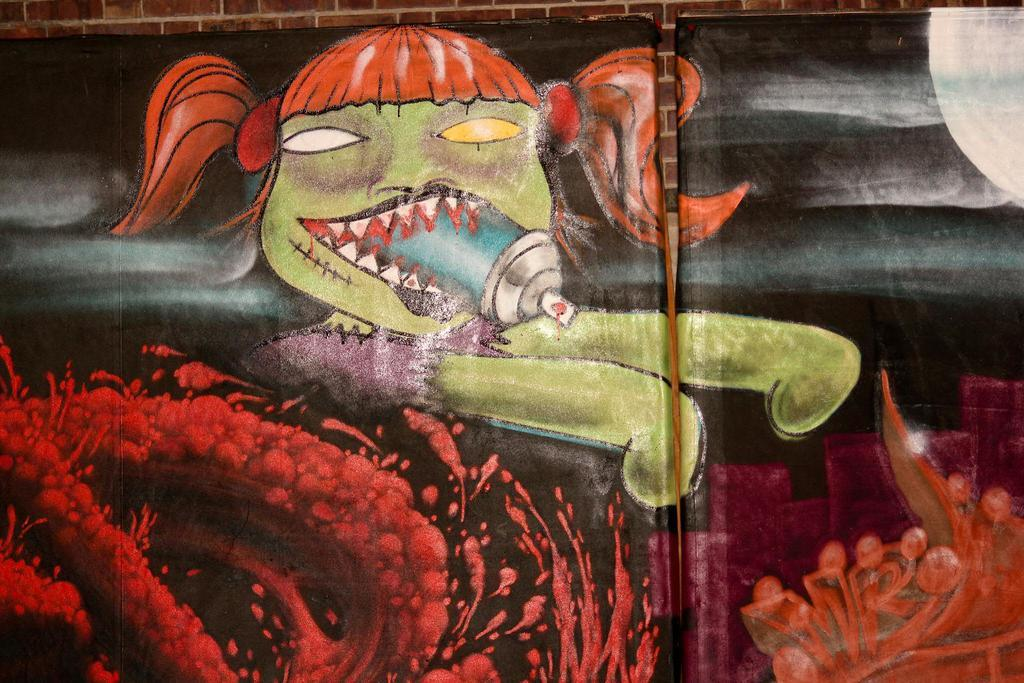What is present on the wall in the image? There is a black-colored chart on the wall. What can be seen on the chart? The chart has paintings drawn on it. Is there a wire attached to the back of the chart in the image? There is no mention of a wire or the back of the chart in the provided facts, so we cannot determine if there is a wire attached to it. 